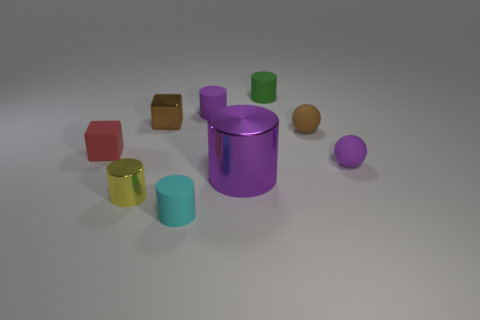Subtract all yellow cylinders. How many cylinders are left? 4 Subtract 1 cylinders. How many cylinders are left? 4 Subtract all tiny cyan cylinders. How many cylinders are left? 4 Subtract all blue cylinders. Subtract all blue spheres. How many cylinders are left? 5 Add 1 matte cylinders. How many objects exist? 10 Subtract all blocks. How many objects are left? 7 Subtract all metallic cubes. Subtract all purple balls. How many objects are left? 7 Add 6 small red matte things. How many small red matte things are left? 7 Add 9 tiny green objects. How many tiny green objects exist? 10 Subtract 1 yellow cylinders. How many objects are left? 8 